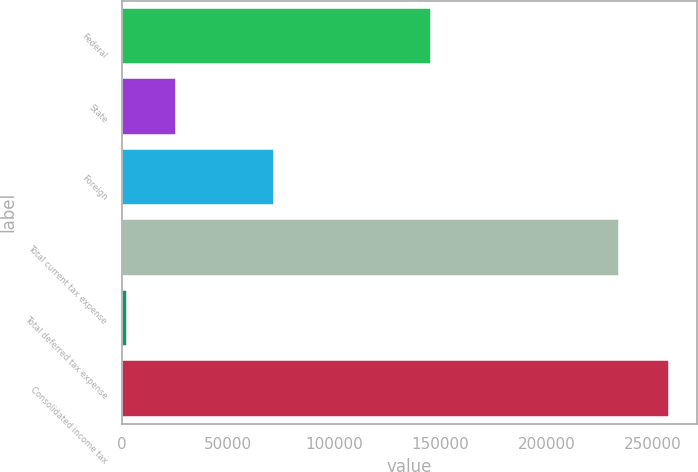<chart> <loc_0><loc_0><loc_500><loc_500><bar_chart><fcel>Federal<fcel>State<fcel>Foreign<fcel>Total current tax expense<fcel>Total deferred tax expense<fcel>Consolidated income tax<nl><fcel>145483<fcel>25742.3<fcel>71625<fcel>234363<fcel>2306<fcel>257799<nl></chart> 